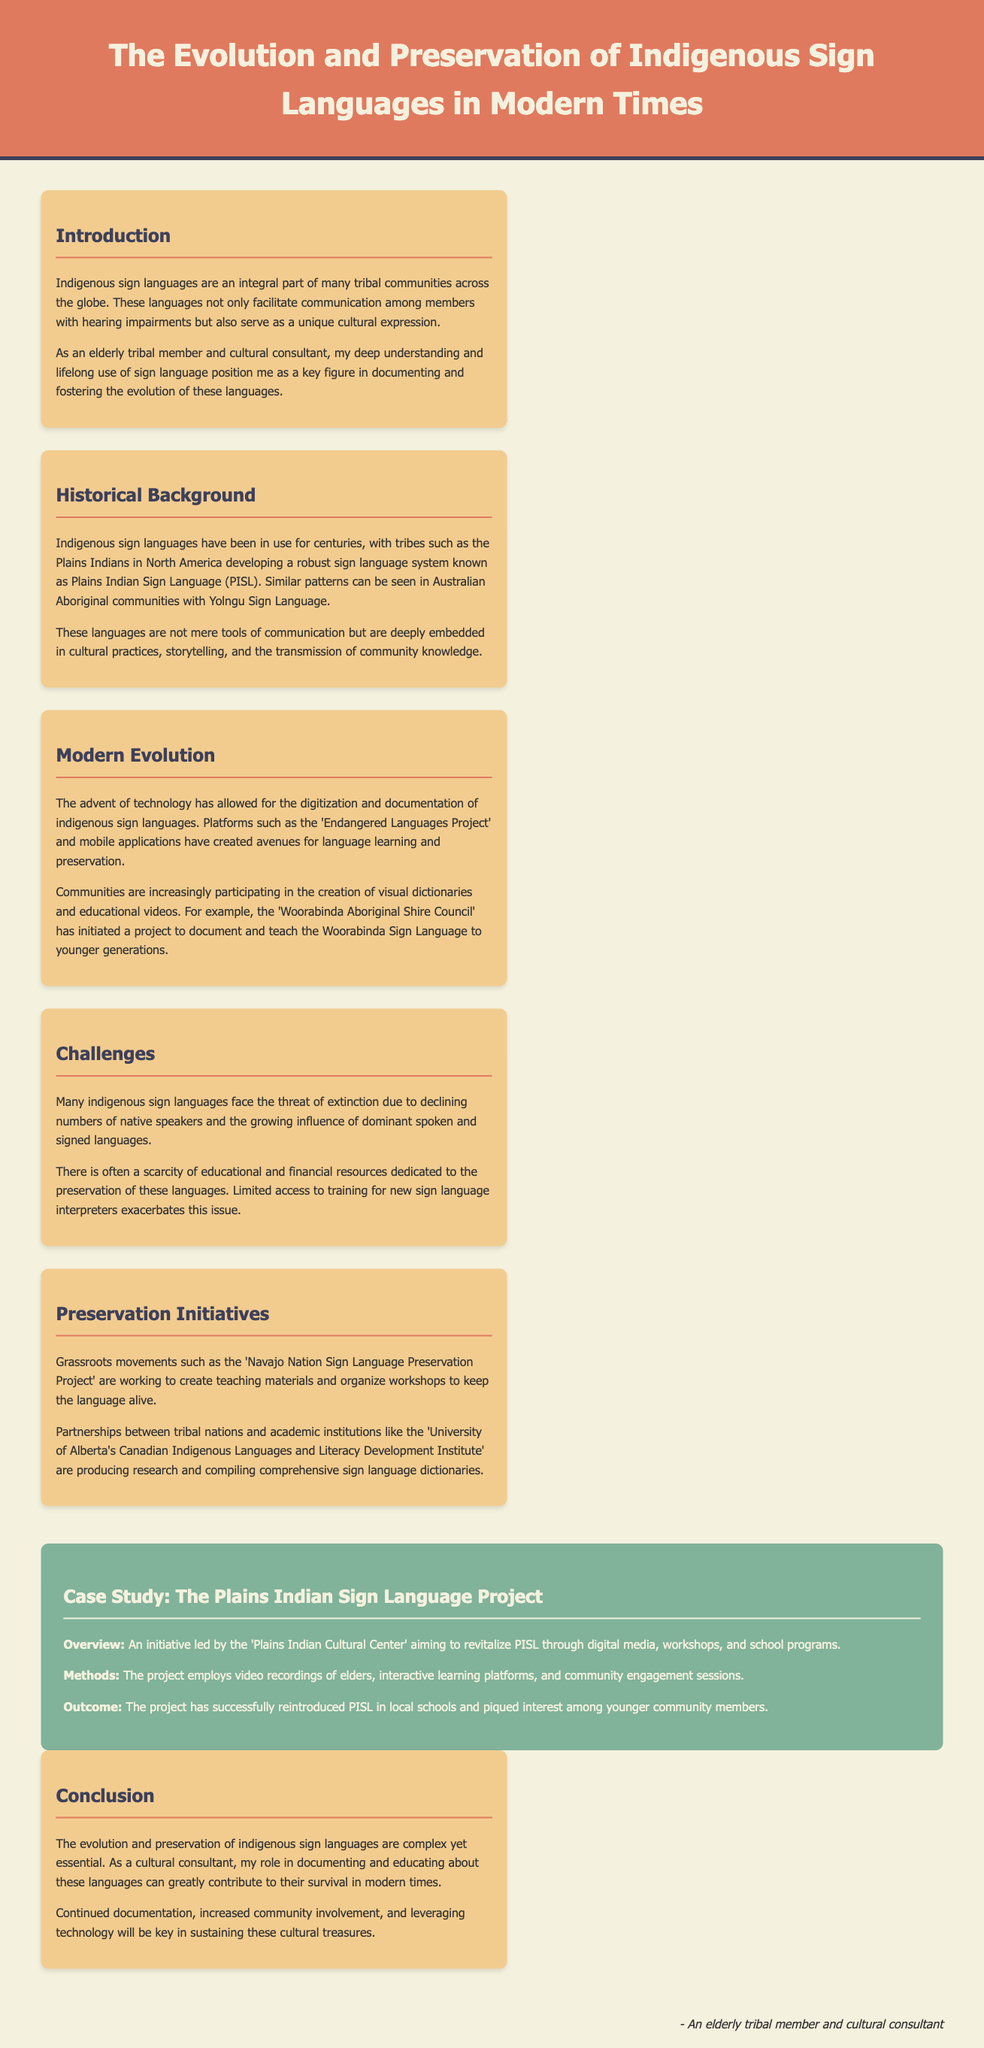what is the title of the case study? The title of the case study is explicitly stated in the document as "The Plains Indian Sign Language Project."
Answer: The Plains Indian Sign Language Project what is the name of the sign language used by Plains Indians? The document mentions that the sign language used by the Plains Indians is called Plains Indian Sign Language (PISL).
Answer: Plains Indian Sign Language (PISL) what type of initiatives are being led by the Navajo Nation? The document states that the Navajo Nation is leading the "Navajo Nation Sign Language Preservation Project" which focuses on preservation efforts.
Answer: Navajo Nation Sign Language Preservation Project how does technology contribute to sign language documentation? According to the document, technology has allowed for the digitization and documentation of indigenous sign languages, creating new avenues for preservation.
Answer: Digitization and documentation what is one major challenge faced by indigenous sign languages? The document highlights declining numbers of native speakers as a major challenge faced by indigenous sign languages.
Answer: Declining numbers what method is used in the Plains Indian Sign Language Project? The document states that the project employs video recordings of elders as one of its methods for revitalization.
Answer: Video recordings of elders who does the conclusion attribute the responsibility of documenting these languages? The conclusion states that it is the role of the author, as a cultural consultant, to document and educate about these languages.
Answer: Cultural consultant what type of community involvement is mentioned for preservation? The document mentions community engagement sessions as a form of involvement in preservation initiatives.
Answer: Community engagement sessions 